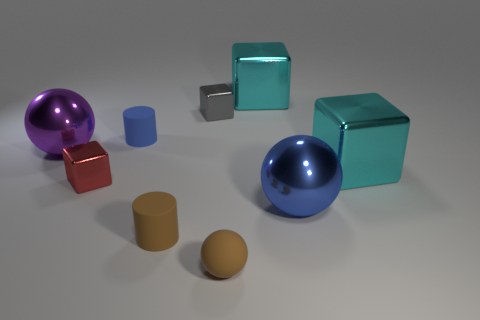Do the purple object and the tiny gray cube have the same material?
Your response must be concise. Yes. What is the size of the other thing that is the same shape as the tiny blue object?
Provide a succinct answer. Small. Does the brown rubber object that is to the right of the gray cube have the same shape as the small metal thing that is to the left of the tiny gray shiny block?
Make the answer very short. No. There is a blue metal ball; is it the same size as the cyan cube that is behind the tiny gray metallic block?
Your answer should be compact. Yes. What number of other objects are the same material as the purple ball?
Your answer should be very brief. 5. Is there anything else that has the same shape as the gray metallic object?
Your answer should be very brief. Yes. There is a large metallic sphere to the right of the tiny brown thing that is on the left side of the small cube that is right of the small red thing; what color is it?
Keep it short and to the point. Blue. What is the shape of the small thing that is to the right of the small blue thing and behind the large purple ball?
Ensure brevity in your answer.  Cube. Are there any other things that are the same size as the blue cylinder?
Offer a terse response. Yes. What is the color of the small metallic thing to the left of the blue object behind the red cube?
Make the answer very short. Red. 